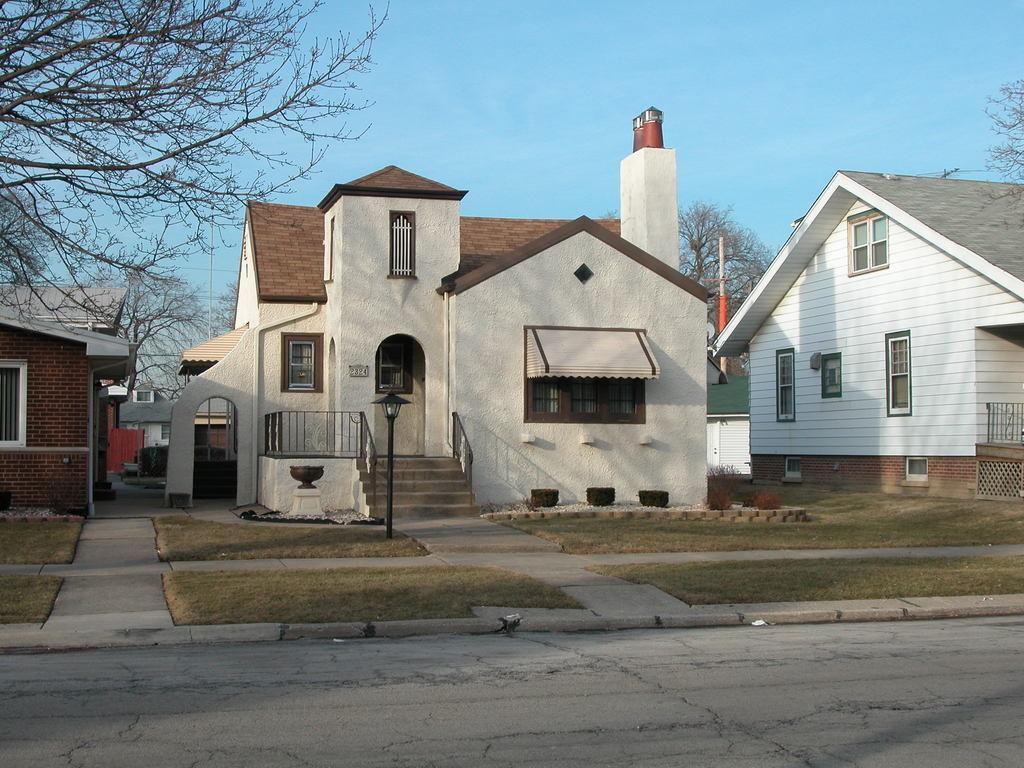Please provide a concise description of this image. In the center of the image we can see building and light pole. On the left side of the image we can see buildings and trees. On the right side there is a building. At the bottom we can see grass and road. In the background there is a sky. 